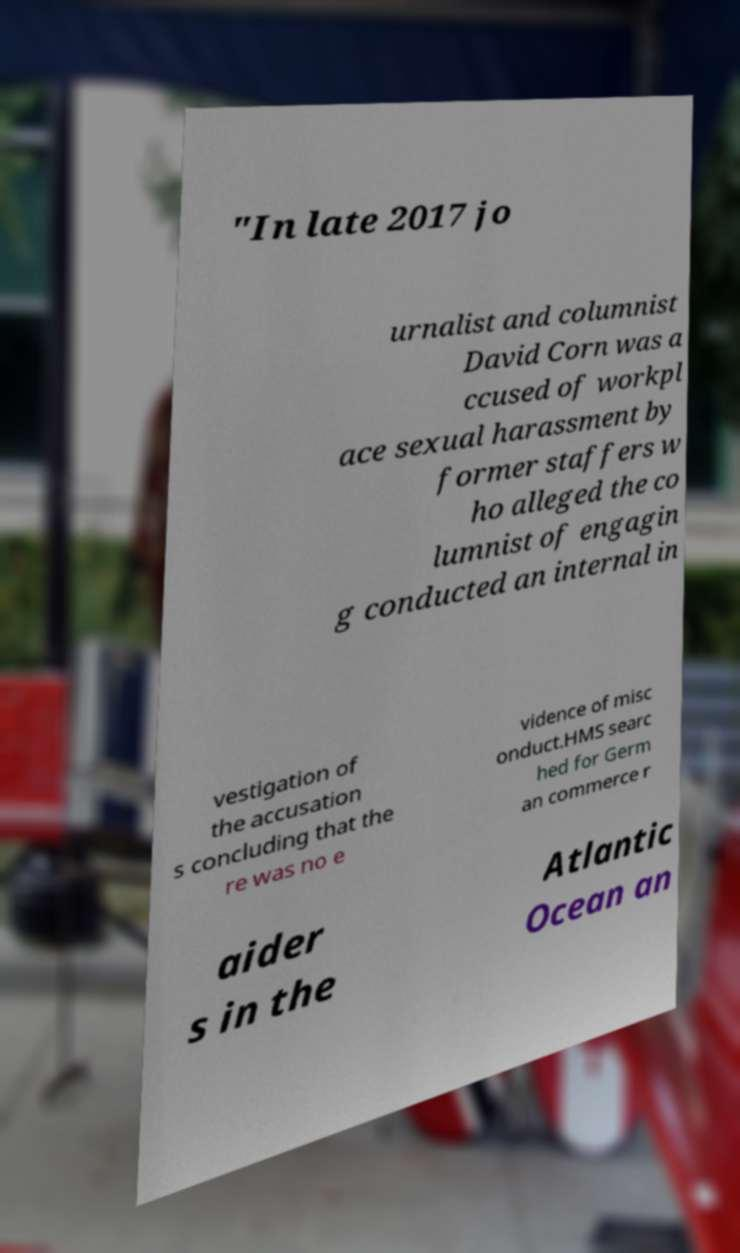There's text embedded in this image that I need extracted. Can you transcribe it verbatim? "In late 2017 jo urnalist and columnist David Corn was a ccused of workpl ace sexual harassment by former staffers w ho alleged the co lumnist of engagin g conducted an internal in vestigation of the accusation s concluding that the re was no e vidence of misc onduct.HMS searc hed for Germ an commerce r aider s in the Atlantic Ocean an 